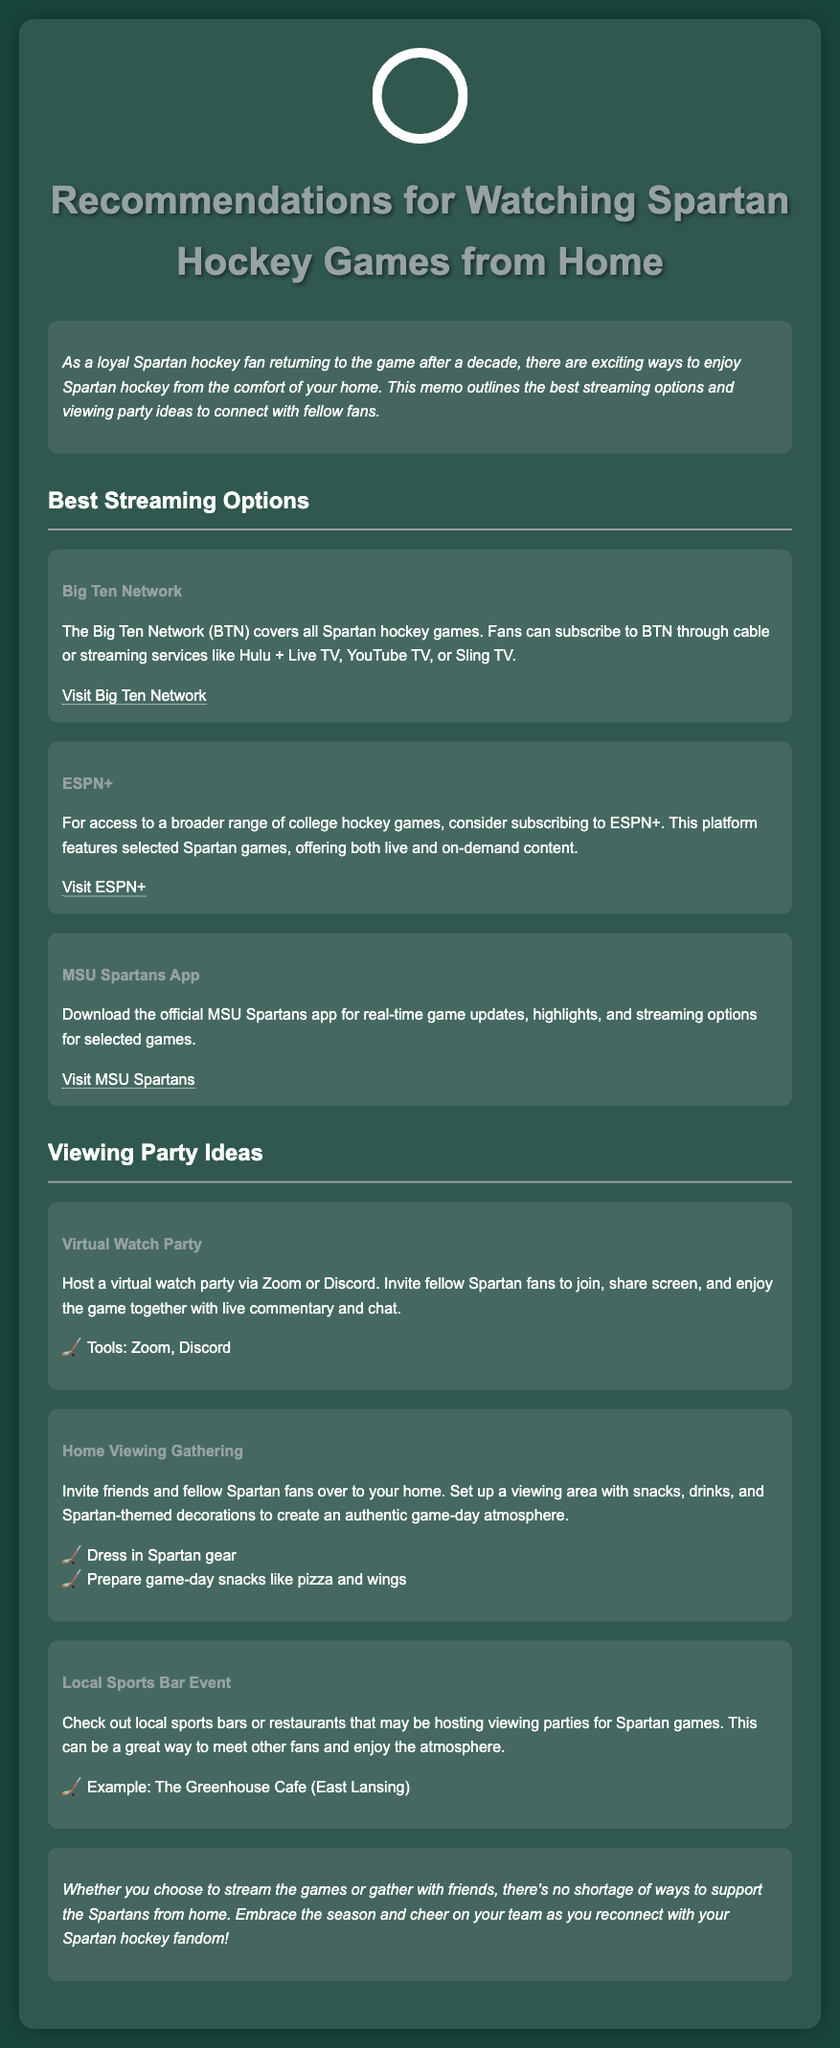what streaming service covers all Spartan hockey games? The Big Ten Network (BTN) covers all Spartan hockey games as stated in the document.
Answer: Big Ten Network what is a platform for broader range of college hockey games? The document mentions ESPN+ for broader access to college hockey games, including selected Spartan games.
Answer: ESPN+ what app can fans download for real-time game updates? The MSU Spartans app is recommended for real-time game updates and highlights.
Answer: MSU Spartans App which viewing party idea involves using Zoom or Discord? The document states that a virtual watch party can be hosted using Zoom or Discord for fellowship among fans.
Answer: Virtual Watch Party what is suggested for creating an authentic game-day atmosphere at home? The document suggests inviting friends over and setting up with snacks, drinks, and decorations for an authentic ambiance.
Answer: Snacks, drinks, Spartan-themed decorations what local venue is an example for a sports bar event? The Greenhouse Cafe is provided as an example of a local sports bar that may host viewing parties for Spartan games.
Answer: The Greenhouse Cafe how many viewing party ideas are mentioned in the document? The document lists three viewing party ideas for fans to consider.
Answer: Three 